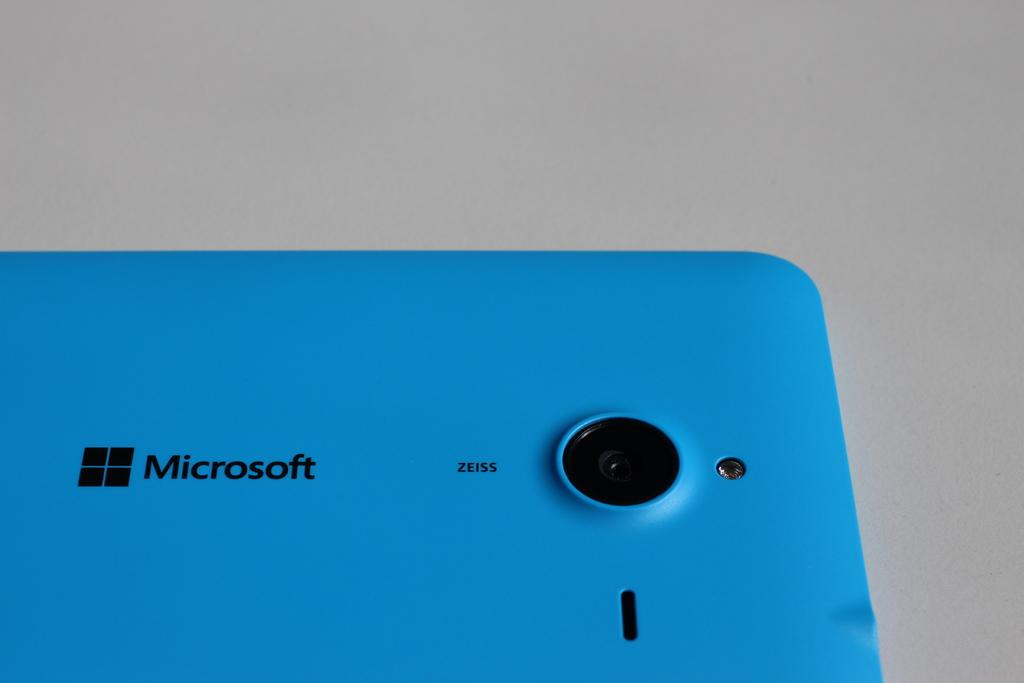<image>
Create a compact narrative representing the image presented. a blue electronic device that says 'microsoft' on the back of it 